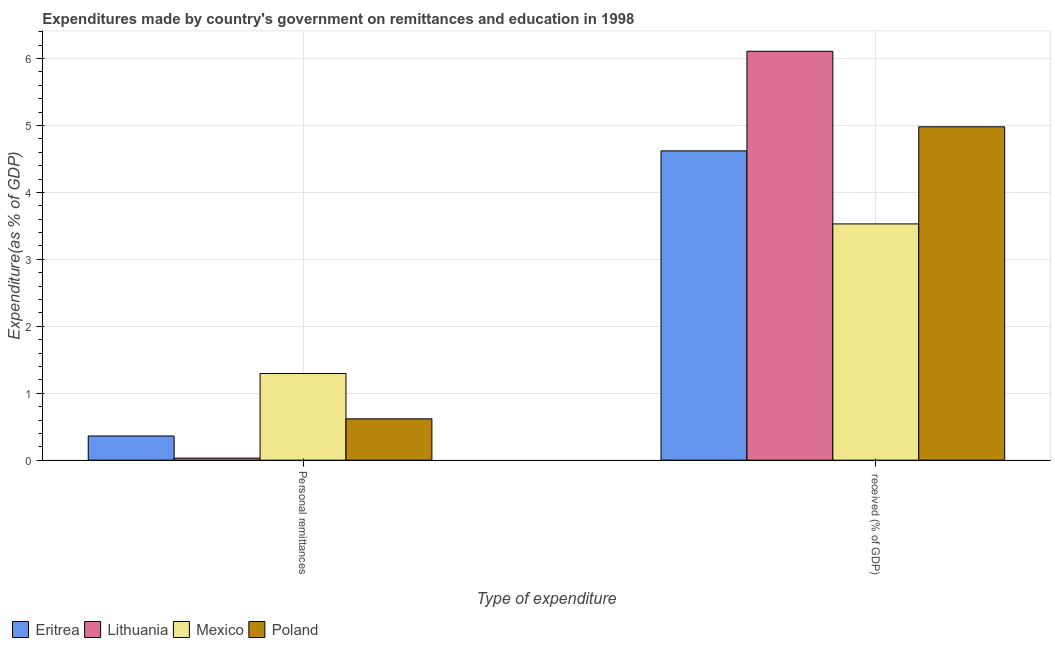How many different coloured bars are there?
Keep it short and to the point. 4. Are the number of bars per tick equal to the number of legend labels?
Your answer should be very brief. Yes. Are the number of bars on each tick of the X-axis equal?
Make the answer very short. Yes. How many bars are there on the 2nd tick from the right?
Give a very brief answer. 4. What is the label of the 1st group of bars from the left?
Your answer should be very brief. Personal remittances. What is the expenditure in personal remittances in Eritrea?
Keep it short and to the point. 0.36. Across all countries, what is the maximum expenditure in personal remittances?
Provide a succinct answer. 1.3. Across all countries, what is the minimum expenditure in personal remittances?
Provide a short and direct response. 0.03. In which country was the expenditure in education maximum?
Offer a very short reply. Lithuania. What is the total expenditure in education in the graph?
Your response must be concise. 19.24. What is the difference between the expenditure in personal remittances in Mexico and that in Poland?
Offer a terse response. 0.68. What is the difference between the expenditure in education in Poland and the expenditure in personal remittances in Eritrea?
Keep it short and to the point. 4.62. What is the average expenditure in personal remittances per country?
Provide a short and direct response. 0.58. What is the difference between the expenditure in personal remittances and expenditure in education in Eritrea?
Give a very brief answer. -4.26. What is the ratio of the expenditure in personal remittances in Mexico to that in Eritrea?
Offer a terse response. 3.59. Is the expenditure in education in Poland less than that in Mexico?
Keep it short and to the point. No. In how many countries, is the expenditure in education greater than the average expenditure in education taken over all countries?
Make the answer very short. 2. What does the 1st bar from the left in  received (% of GDP) represents?
Your answer should be compact. Eritrea. Are all the bars in the graph horizontal?
Provide a short and direct response. No. Are the values on the major ticks of Y-axis written in scientific E-notation?
Your answer should be compact. No. Does the graph contain any zero values?
Provide a short and direct response. No. How many legend labels are there?
Your answer should be very brief. 4. How are the legend labels stacked?
Your answer should be very brief. Horizontal. What is the title of the graph?
Provide a succinct answer. Expenditures made by country's government on remittances and education in 1998. Does "Panama" appear as one of the legend labels in the graph?
Give a very brief answer. No. What is the label or title of the X-axis?
Offer a terse response. Type of expenditure. What is the label or title of the Y-axis?
Provide a short and direct response. Expenditure(as % of GDP). What is the Expenditure(as % of GDP) in Eritrea in Personal remittances?
Your answer should be compact. 0.36. What is the Expenditure(as % of GDP) in Lithuania in Personal remittances?
Keep it short and to the point. 0.03. What is the Expenditure(as % of GDP) of Mexico in Personal remittances?
Your answer should be very brief. 1.3. What is the Expenditure(as % of GDP) in Poland in Personal remittances?
Your response must be concise. 0.62. What is the Expenditure(as % of GDP) in Eritrea in  received (% of GDP)?
Offer a terse response. 4.62. What is the Expenditure(as % of GDP) of Lithuania in  received (% of GDP)?
Offer a terse response. 6.11. What is the Expenditure(as % of GDP) in Mexico in  received (% of GDP)?
Your answer should be compact. 3.53. What is the Expenditure(as % of GDP) in Poland in  received (% of GDP)?
Ensure brevity in your answer.  4.98. Across all Type of expenditure, what is the maximum Expenditure(as % of GDP) in Eritrea?
Your answer should be very brief. 4.62. Across all Type of expenditure, what is the maximum Expenditure(as % of GDP) in Lithuania?
Provide a short and direct response. 6.11. Across all Type of expenditure, what is the maximum Expenditure(as % of GDP) of Mexico?
Your response must be concise. 3.53. Across all Type of expenditure, what is the maximum Expenditure(as % of GDP) of Poland?
Offer a very short reply. 4.98. Across all Type of expenditure, what is the minimum Expenditure(as % of GDP) of Eritrea?
Your response must be concise. 0.36. Across all Type of expenditure, what is the minimum Expenditure(as % of GDP) of Lithuania?
Ensure brevity in your answer.  0.03. Across all Type of expenditure, what is the minimum Expenditure(as % of GDP) in Mexico?
Make the answer very short. 1.3. Across all Type of expenditure, what is the minimum Expenditure(as % of GDP) in Poland?
Make the answer very short. 0.62. What is the total Expenditure(as % of GDP) of Eritrea in the graph?
Keep it short and to the point. 4.98. What is the total Expenditure(as % of GDP) in Lithuania in the graph?
Your answer should be very brief. 6.14. What is the total Expenditure(as % of GDP) of Mexico in the graph?
Offer a terse response. 4.82. What is the total Expenditure(as % of GDP) in Poland in the graph?
Provide a short and direct response. 5.6. What is the difference between the Expenditure(as % of GDP) of Eritrea in Personal remittances and that in  received (% of GDP)?
Offer a terse response. -4.26. What is the difference between the Expenditure(as % of GDP) of Lithuania in Personal remittances and that in  received (% of GDP)?
Offer a terse response. -6.08. What is the difference between the Expenditure(as % of GDP) of Mexico in Personal remittances and that in  received (% of GDP)?
Provide a short and direct response. -2.23. What is the difference between the Expenditure(as % of GDP) of Poland in Personal remittances and that in  received (% of GDP)?
Make the answer very short. -4.36. What is the difference between the Expenditure(as % of GDP) of Eritrea in Personal remittances and the Expenditure(as % of GDP) of Lithuania in  received (% of GDP)?
Your response must be concise. -5.75. What is the difference between the Expenditure(as % of GDP) of Eritrea in Personal remittances and the Expenditure(as % of GDP) of Mexico in  received (% of GDP)?
Your response must be concise. -3.17. What is the difference between the Expenditure(as % of GDP) of Eritrea in Personal remittances and the Expenditure(as % of GDP) of Poland in  received (% of GDP)?
Keep it short and to the point. -4.62. What is the difference between the Expenditure(as % of GDP) in Lithuania in Personal remittances and the Expenditure(as % of GDP) in Mexico in  received (% of GDP)?
Make the answer very short. -3.5. What is the difference between the Expenditure(as % of GDP) of Lithuania in Personal remittances and the Expenditure(as % of GDP) of Poland in  received (% of GDP)?
Offer a terse response. -4.95. What is the difference between the Expenditure(as % of GDP) of Mexico in Personal remittances and the Expenditure(as % of GDP) of Poland in  received (% of GDP)?
Keep it short and to the point. -3.69. What is the average Expenditure(as % of GDP) in Eritrea per Type of expenditure?
Your answer should be very brief. 2.49. What is the average Expenditure(as % of GDP) of Lithuania per Type of expenditure?
Offer a terse response. 3.07. What is the average Expenditure(as % of GDP) in Mexico per Type of expenditure?
Keep it short and to the point. 2.41. What is the average Expenditure(as % of GDP) in Poland per Type of expenditure?
Keep it short and to the point. 2.8. What is the difference between the Expenditure(as % of GDP) of Eritrea and Expenditure(as % of GDP) of Lithuania in Personal remittances?
Offer a terse response. 0.33. What is the difference between the Expenditure(as % of GDP) in Eritrea and Expenditure(as % of GDP) in Mexico in Personal remittances?
Your response must be concise. -0.93. What is the difference between the Expenditure(as % of GDP) of Eritrea and Expenditure(as % of GDP) of Poland in Personal remittances?
Ensure brevity in your answer.  -0.26. What is the difference between the Expenditure(as % of GDP) of Lithuania and Expenditure(as % of GDP) of Mexico in Personal remittances?
Your answer should be very brief. -1.26. What is the difference between the Expenditure(as % of GDP) of Lithuania and Expenditure(as % of GDP) of Poland in Personal remittances?
Give a very brief answer. -0.59. What is the difference between the Expenditure(as % of GDP) in Mexico and Expenditure(as % of GDP) in Poland in Personal remittances?
Keep it short and to the point. 0.68. What is the difference between the Expenditure(as % of GDP) of Eritrea and Expenditure(as % of GDP) of Lithuania in  received (% of GDP)?
Keep it short and to the point. -1.49. What is the difference between the Expenditure(as % of GDP) of Eritrea and Expenditure(as % of GDP) of Mexico in  received (% of GDP)?
Offer a very short reply. 1.09. What is the difference between the Expenditure(as % of GDP) of Eritrea and Expenditure(as % of GDP) of Poland in  received (% of GDP)?
Your answer should be very brief. -0.36. What is the difference between the Expenditure(as % of GDP) of Lithuania and Expenditure(as % of GDP) of Mexico in  received (% of GDP)?
Make the answer very short. 2.58. What is the difference between the Expenditure(as % of GDP) in Lithuania and Expenditure(as % of GDP) in Poland in  received (% of GDP)?
Give a very brief answer. 1.13. What is the difference between the Expenditure(as % of GDP) of Mexico and Expenditure(as % of GDP) of Poland in  received (% of GDP)?
Make the answer very short. -1.45. What is the ratio of the Expenditure(as % of GDP) in Eritrea in Personal remittances to that in  received (% of GDP)?
Make the answer very short. 0.08. What is the ratio of the Expenditure(as % of GDP) in Lithuania in Personal remittances to that in  received (% of GDP)?
Ensure brevity in your answer.  0.01. What is the ratio of the Expenditure(as % of GDP) of Mexico in Personal remittances to that in  received (% of GDP)?
Provide a short and direct response. 0.37. What is the ratio of the Expenditure(as % of GDP) of Poland in Personal remittances to that in  received (% of GDP)?
Offer a terse response. 0.12. What is the difference between the highest and the second highest Expenditure(as % of GDP) of Eritrea?
Your answer should be compact. 4.26. What is the difference between the highest and the second highest Expenditure(as % of GDP) in Lithuania?
Give a very brief answer. 6.08. What is the difference between the highest and the second highest Expenditure(as % of GDP) of Mexico?
Make the answer very short. 2.23. What is the difference between the highest and the second highest Expenditure(as % of GDP) in Poland?
Give a very brief answer. 4.36. What is the difference between the highest and the lowest Expenditure(as % of GDP) of Eritrea?
Your response must be concise. 4.26. What is the difference between the highest and the lowest Expenditure(as % of GDP) of Lithuania?
Offer a terse response. 6.08. What is the difference between the highest and the lowest Expenditure(as % of GDP) of Mexico?
Give a very brief answer. 2.23. What is the difference between the highest and the lowest Expenditure(as % of GDP) of Poland?
Your response must be concise. 4.36. 